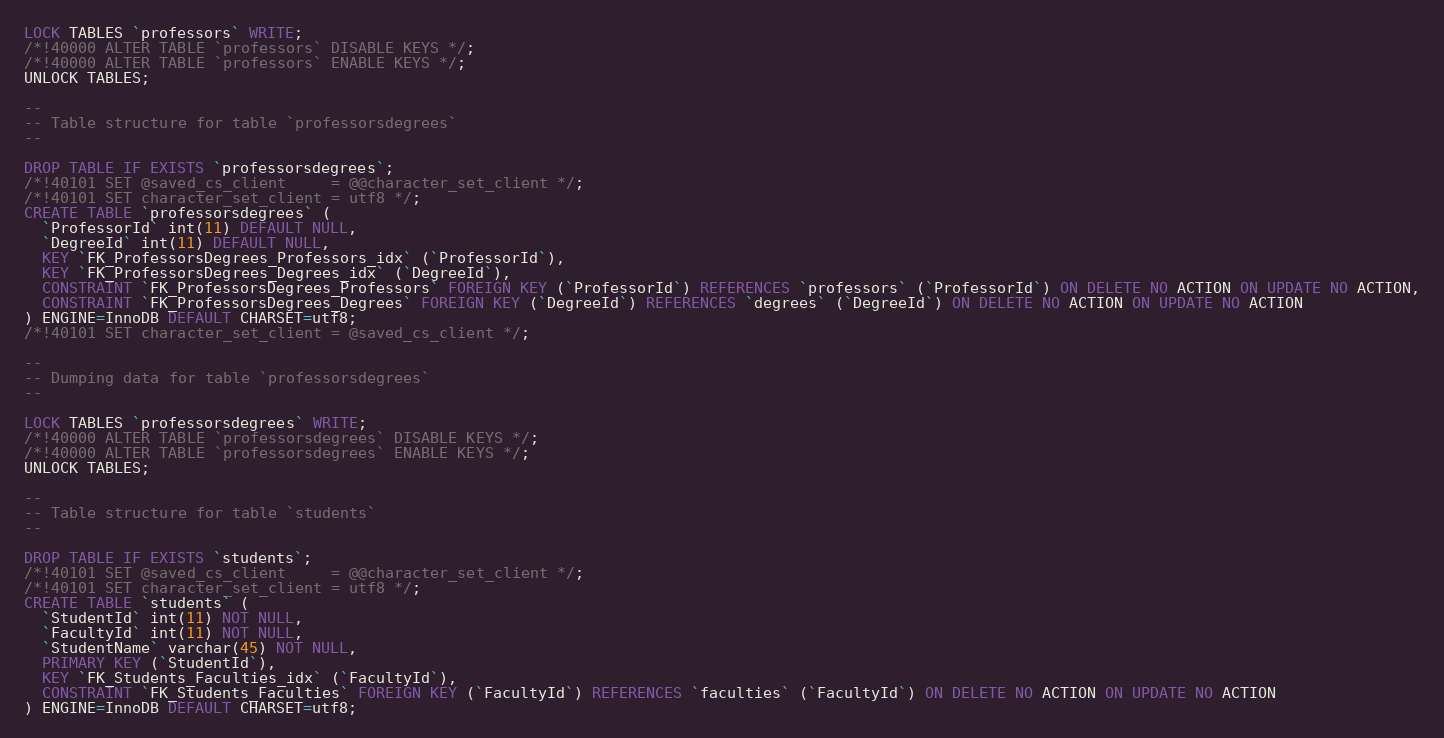Convert code to text. <code><loc_0><loc_0><loc_500><loc_500><_SQL_>LOCK TABLES `professors` WRITE;
/*!40000 ALTER TABLE `professors` DISABLE KEYS */;
/*!40000 ALTER TABLE `professors` ENABLE KEYS */;
UNLOCK TABLES;

--
-- Table structure for table `professorsdegrees`
--

DROP TABLE IF EXISTS `professorsdegrees`;
/*!40101 SET @saved_cs_client     = @@character_set_client */;
/*!40101 SET character_set_client = utf8 */;
CREATE TABLE `professorsdegrees` (
  `ProfessorId` int(11) DEFAULT NULL,
  `DegreeId` int(11) DEFAULT NULL,
  KEY `FK_ProfessorsDegrees_Professors_idx` (`ProfessorId`),
  KEY `FK_ProfessorsDegrees_Degrees_idx` (`DegreeId`),
  CONSTRAINT `FK_ProfessorsDegrees_Professors` FOREIGN KEY (`ProfessorId`) REFERENCES `professors` (`ProfessorId`) ON DELETE NO ACTION ON UPDATE NO ACTION,
  CONSTRAINT `FK_ProfessorsDegrees_Degrees` FOREIGN KEY (`DegreeId`) REFERENCES `degrees` (`DegreeId`) ON DELETE NO ACTION ON UPDATE NO ACTION
) ENGINE=InnoDB DEFAULT CHARSET=utf8;
/*!40101 SET character_set_client = @saved_cs_client */;

--
-- Dumping data for table `professorsdegrees`
--

LOCK TABLES `professorsdegrees` WRITE;
/*!40000 ALTER TABLE `professorsdegrees` DISABLE KEYS */;
/*!40000 ALTER TABLE `professorsdegrees` ENABLE KEYS */;
UNLOCK TABLES;

--
-- Table structure for table `students`
--

DROP TABLE IF EXISTS `students`;
/*!40101 SET @saved_cs_client     = @@character_set_client */;
/*!40101 SET character_set_client = utf8 */;
CREATE TABLE `students` (
  `StudentId` int(11) NOT NULL,
  `FacultyId` int(11) NOT NULL,
  `StudentName` varchar(45) NOT NULL,
  PRIMARY KEY (`StudentId`),
  KEY `FK_Students_Faculties_idx` (`FacultyId`),
  CONSTRAINT `FK_Students_Faculties` FOREIGN KEY (`FacultyId`) REFERENCES `faculties` (`FacultyId`) ON DELETE NO ACTION ON UPDATE NO ACTION
) ENGINE=InnoDB DEFAULT CHARSET=utf8;</code> 